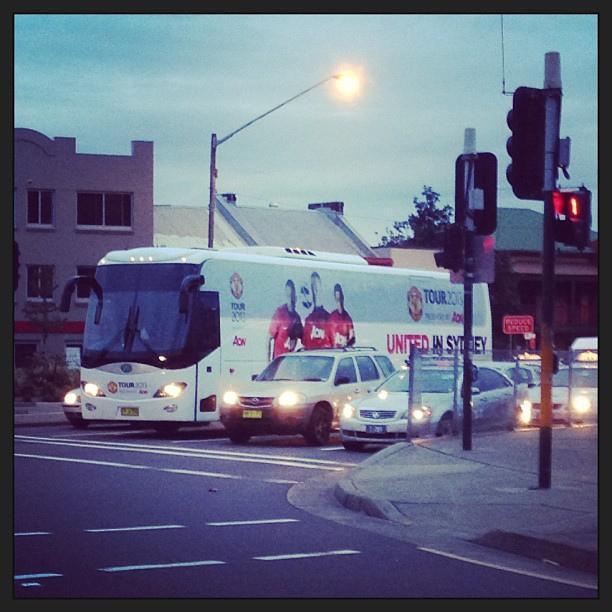How many cars are in the photo?
Give a very brief answer. 3. How many traffic lights are there?
Give a very brief answer. 3. How many kites are flying in the sky?
Give a very brief answer. 0. 